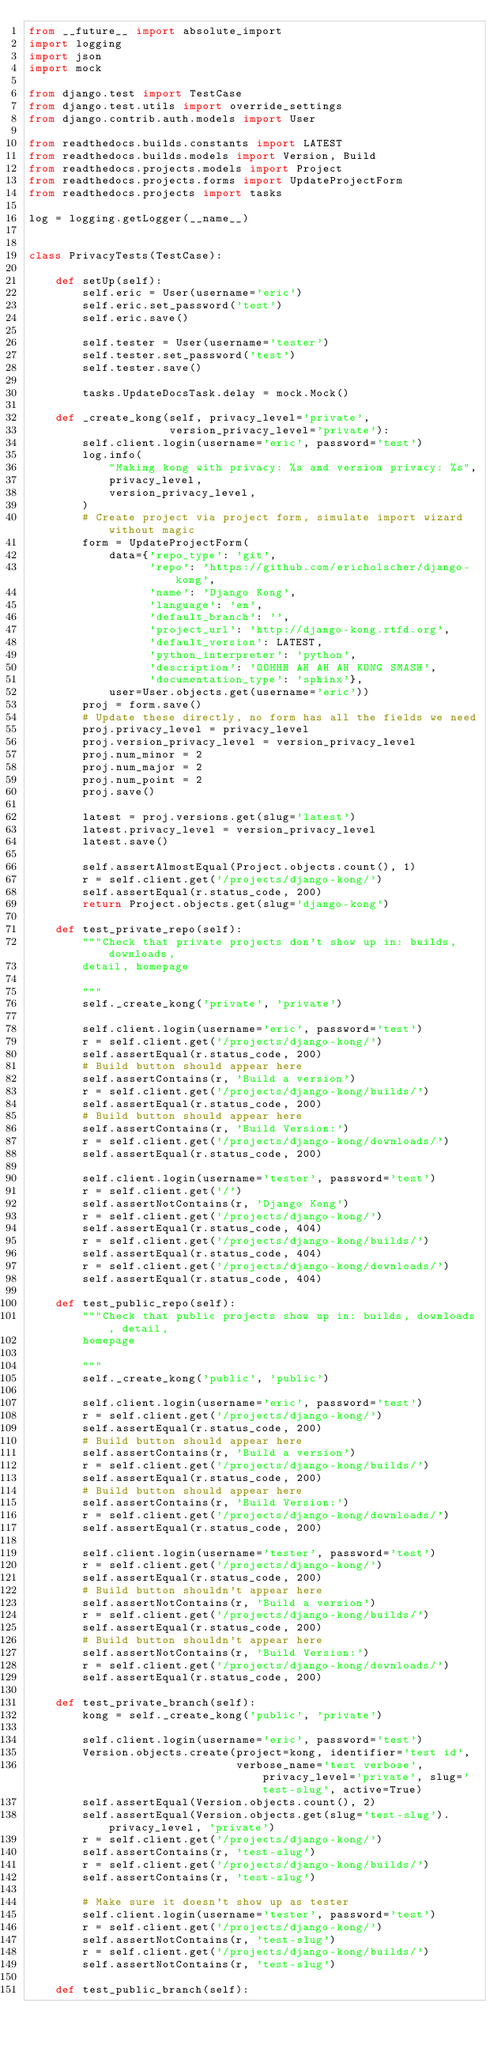Convert code to text. <code><loc_0><loc_0><loc_500><loc_500><_Python_>from __future__ import absolute_import
import logging
import json
import mock

from django.test import TestCase
from django.test.utils import override_settings
from django.contrib.auth.models import User

from readthedocs.builds.constants import LATEST
from readthedocs.builds.models import Version, Build
from readthedocs.projects.models import Project
from readthedocs.projects.forms import UpdateProjectForm
from readthedocs.projects import tasks

log = logging.getLogger(__name__)


class PrivacyTests(TestCase):

    def setUp(self):
        self.eric = User(username='eric')
        self.eric.set_password('test')
        self.eric.save()

        self.tester = User(username='tester')
        self.tester.set_password('test')
        self.tester.save()

        tasks.UpdateDocsTask.delay = mock.Mock()

    def _create_kong(self, privacy_level='private',
                     version_privacy_level='private'):
        self.client.login(username='eric', password='test')
        log.info(
            "Making kong with privacy: %s and version privacy: %s",
            privacy_level,
            version_privacy_level,
        )
        # Create project via project form, simulate import wizard without magic
        form = UpdateProjectForm(
            data={'repo_type': 'git',
                  'repo': 'https://github.com/ericholscher/django-kong',
                  'name': 'Django Kong',
                  'language': 'en',
                  'default_branch': '',
                  'project_url': 'http://django-kong.rtfd.org',
                  'default_version': LATEST,
                  'python_interpreter': 'python',
                  'description': 'OOHHH AH AH AH KONG SMASH',
                  'documentation_type': 'sphinx'},
            user=User.objects.get(username='eric'))
        proj = form.save()
        # Update these directly, no form has all the fields we need
        proj.privacy_level = privacy_level
        proj.version_privacy_level = version_privacy_level
        proj.num_minor = 2
        proj.num_major = 2
        proj.num_point = 2
        proj.save()

        latest = proj.versions.get(slug='latest')
        latest.privacy_level = version_privacy_level
        latest.save()

        self.assertAlmostEqual(Project.objects.count(), 1)
        r = self.client.get('/projects/django-kong/')
        self.assertEqual(r.status_code, 200)
        return Project.objects.get(slug='django-kong')

    def test_private_repo(self):
        """Check that private projects don't show up in: builds, downloads,
        detail, homepage

        """
        self._create_kong('private', 'private')

        self.client.login(username='eric', password='test')
        r = self.client.get('/projects/django-kong/')
        self.assertEqual(r.status_code, 200)
        # Build button should appear here
        self.assertContains(r, 'Build a version')
        r = self.client.get('/projects/django-kong/builds/')
        self.assertEqual(r.status_code, 200)
        # Build button should appear here
        self.assertContains(r, 'Build Version:')
        r = self.client.get('/projects/django-kong/downloads/')
        self.assertEqual(r.status_code, 200)

        self.client.login(username='tester', password='test')
        r = self.client.get('/')
        self.assertNotContains(r, 'Django Kong')
        r = self.client.get('/projects/django-kong/')
        self.assertEqual(r.status_code, 404)
        r = self.client.get('/projects/django-kong/builds/')
        self.assertEqual(r.status_code, 404)
        r = self.client.get('/projects/django-kong/downloads/')
        self.assertEqual(r.status_code, 404)

    def test_public_repo(self):
        """Check that public projects show up in: builds, downloads, detail,
        homepage

        """
        self._create_kong('public', 'public')

        self.client.login(username='eric', password='test')
        r = self.client.get('/projects/django-kong/')
        self.assertEqual(r.status_code, 200)
        # Build button should appear here
        self.assertContains(r, 'Build a version')
        r = self.client.get('/projects/django-kong/builds/')
        self.assertEqual(r.status_code, 200)
        # Build button should appear here
        self.assertContains(r, 'Build Version:')
        r = self.client.get('/projects/django-kong/downloads/')
        self.assertEqual(r.status_code, 200)

        self.client.login(username='tester', password='test')
        r = self.client.get('/projects/django-kong/')
        self.assertEqual(r.status_code, 200)
        # Build button shouldn't appear here
        self.assertNotContains(r, 'Build a version')
        r = self.client.get('/projects/django-kong/builds/')
        self.assertEqual(r.status_code, 200)
        # Build button shouldn't appear here
        self.assertNotContains(r, 'Build Version:')
        r = self.client.get('/projects/django-kong/downloads/')
        self.assertEqual(r.status_code, 200)

    def test_private_branch(self):
        kong = self._create_kong('public', 'private')

        self.client.login(username='eric', password='test')
        Version.objects.create(project=kong, identifier='test id',
                               verbose_name='test verbose', privacy_level='private', slug='test-slug', active=True)
        self.assertEqual(Version.objects.count(), 2)
        self.assertEqual(Version.objects.get(slug='test-slug').privacy_level, 'private')
        r = self.client.get('/projects/django-kong/')
        self.assertContains(r, 'test-slug')
        r = self.client.get('/projects/django-kong/builds/')
        self.assertContains(r, 'test-slug')

        # Make sure it doesn't show up as tester
        self.client.login(username='tester', password='test')
        r = self.client.get('/projects/django-kong/')
        self.assertNotContains(r, 'test-slug')
        r = self.client.get('/projects/django-kong/builds/')
        self.assertNotContains(r, 'test-slug')

    def test_public_branch(self):</code> 